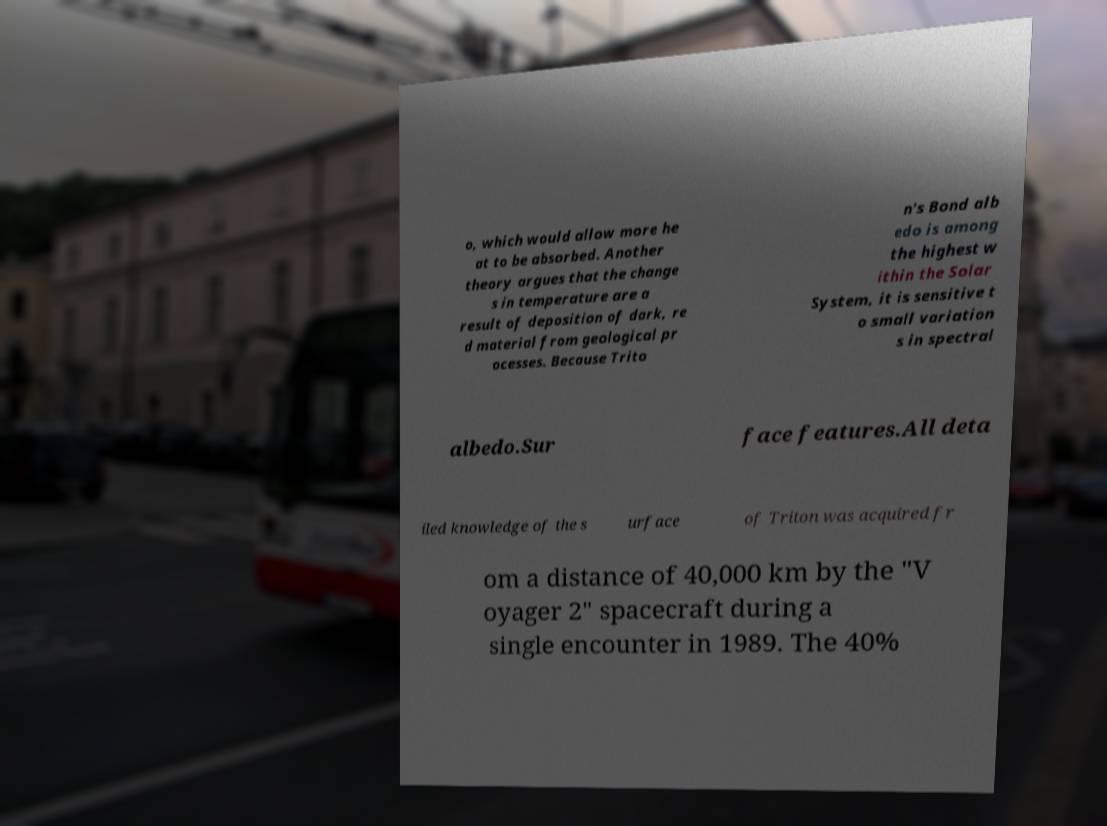Please read and relay the text visible in this image. What does it say? o, which would allow more he at to be absorbed. Another theory argues that the change s in temperature are a result of deposition of dark, re d material from geological pr ocesses. Because Trito n's Bond alb edo is among the highest w ithin the Solar System, it is sensitive t o small variation s in spectral albedo.Sur face features.All deta iled knowledge of the s urface of Triton was acquired fr om a distance of 40,000 km by the "V oyager 2" spacecraft during a single encounter in 1989. The 40% 